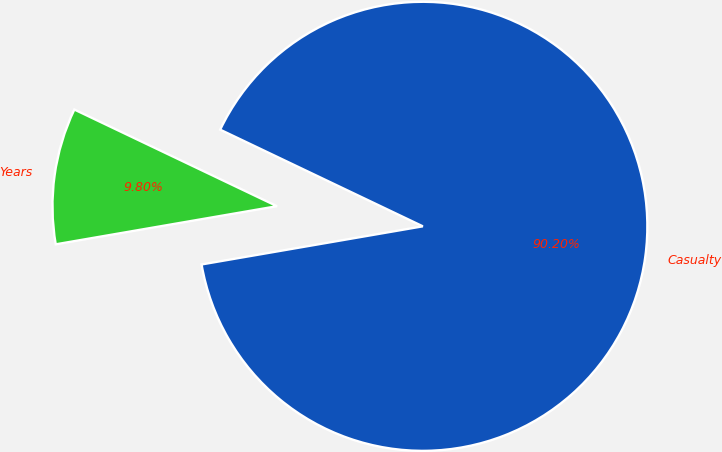Convert chart to OTSL. <chart><loc_0><loc_0><loc_500><loc_500><pie_chart><fcel>Years<fcel>Casualty<nl><fcel>9.8%<fcel>90.2%<nl></chart> 